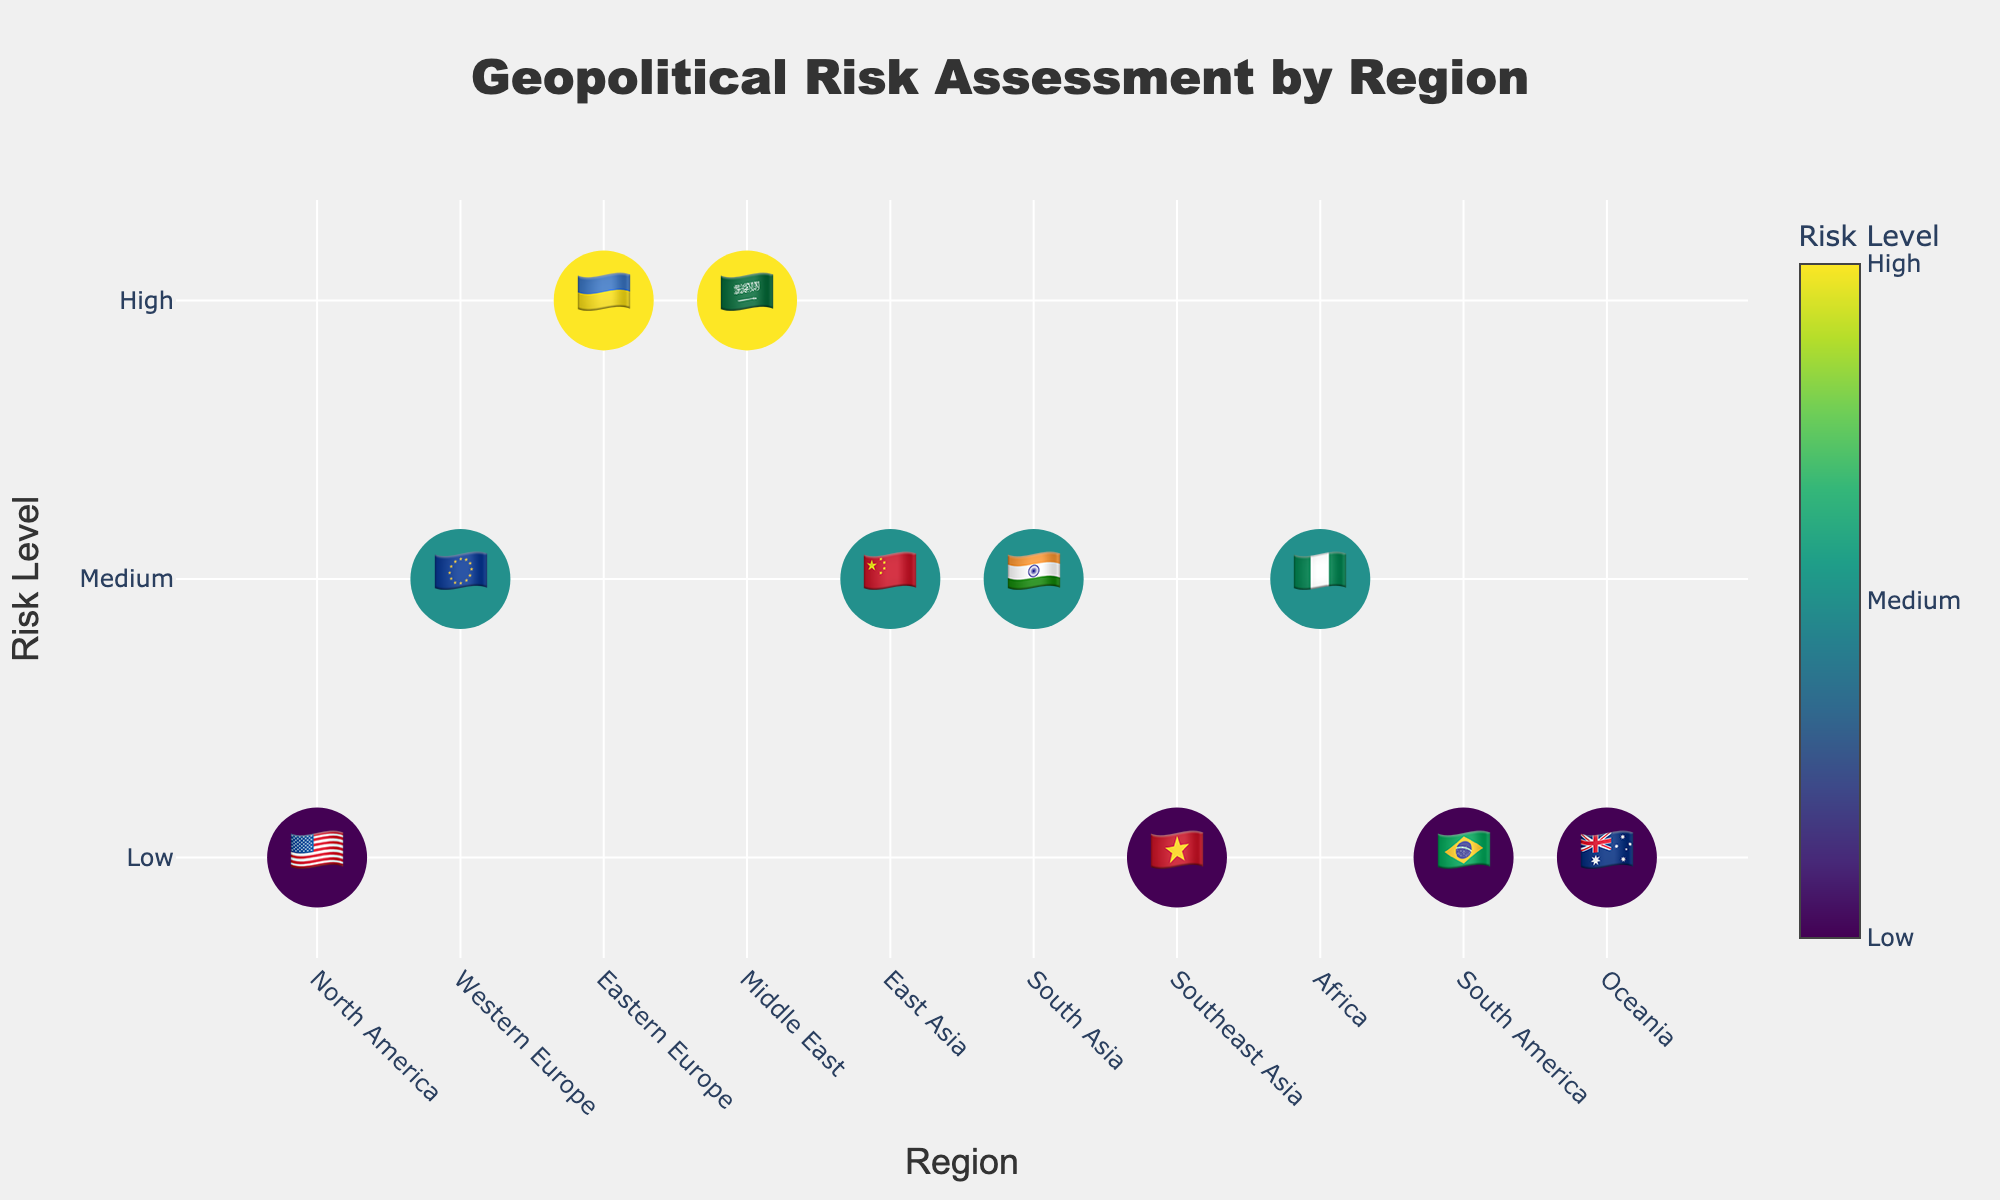What title is displayed at the top of the figure? The title is located at the top center of the figure. The text denotes the overarching theme of the data visualization. It reads 'Geopolitical Risk Assessment by Region'.
Answer: 'Geopolitical Risk Assessment by Region' Which region has the highest risk level? The region with the highest risk level is represented with the highest numeric value on the y-axis, marked in the color scale as 'High'. Eastern Europe (🇺🇦) and the Middle East (🇸🇦) fall under this category.
Answer: Eastern Europe (🇺🇦) and Middle East (🇸🇦) What is the key concern for Western Europe? By hovering over the Western Europe (🇪🇺) point on the graph, the tooltip reveals the key concern associated with the region, which is 'Energy security'.
Answer: Energy security How many regions are assessed as having low risk? The figure displays the risk levels through color intensities and numeric values on the y-axis. 'Low' risk is represented by the lowest numeric value. Regions like North America (🇺🇸), Southeast Asia (🇻🇳), South America (🇧🇷), and Oceania (🇦🇺) fall in this category. By counting these regions, we find there are four.
Answer: Four Which region has a higher risk level: East Asia or South Asia? To determine this, compare the numeric values on the y-axis for both East Asia (🇨🇳) and South Asia (🇮🇳). Both regions are marked at the same numeric value corresponding to 'Medium' risk. Therefore, they have the same risk level.
Answer: They have the same risk level Compare the risk levels of Africa and Oceania. Look at the numeric values on the y-axis for Africa (🇳🇬) and Oceania (🇦🇺). Africa's risk level is medium, while Oceania's risk level is low on the scale. Africa therefore has a higher risk level than Oceania.
Answer: Africa has a higher risk level What is the common key concern among regions with 'Medium' risk levels? Hovering over each region marked with 'Medium' risk on the y-axis (Western Europe, East Asia, South Asia, Africa) reveals their key concerns: 'Energy security', 'Trade tensions', 'Border disputes', and 'Resource conflicts' respectively. Identifying any recurring concern among these shows that there isn't a common key concern for all 'Medium' risk regions.
Answer: No common key concern What do the different colors in the markers indicate? The colors of the markers correspond to the risk levels of each region. The color scale ranges from low (lighter color) to high (darker color) as indicated in the color bar legend titled 'Risk Level'.
Answer: They indicate different risk levels Which regions have political instability as their key concern? Hovering over the individual plot points displays the key concerns. The Middle East (🇸🇦) is identified with 'Political instability' as a key concern.
Answer: Middle East (🇸🇦) What are the risk levels for all North American and South American regions? Hover over both North America (🇺🇸) and South America (🇧🇷) markers. The tooltip reveals 'Low' risk levels for both regions as seen on the y-axis and confirmed by their color intensity.
Answer: Low for both 